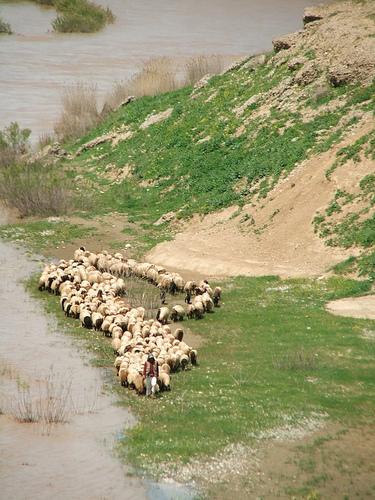What color are the animals?
Keep it brief. White. Is the water clear?
Give a very brief answer. No. Who is in the front of the sheep?
Concise answer only. Man. What herd of animals are in this photo?
Concise answer only. Sheep. 